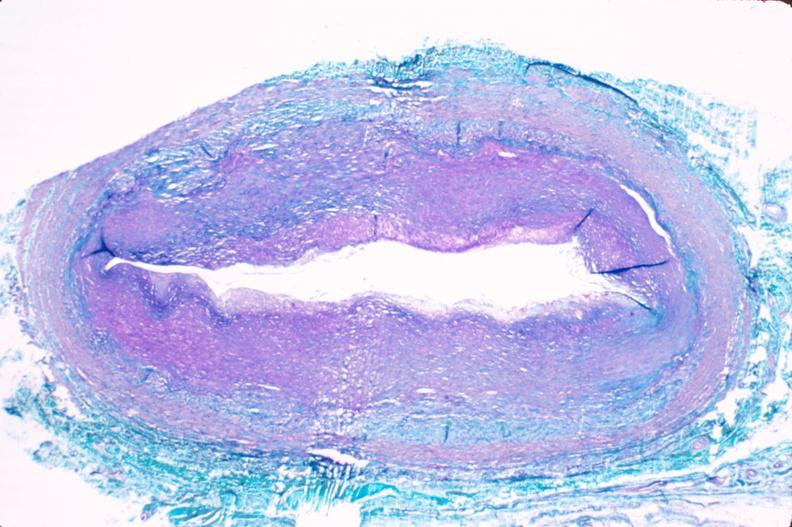s vasculature present?
Answer the question using a single word or phrase. Yes 